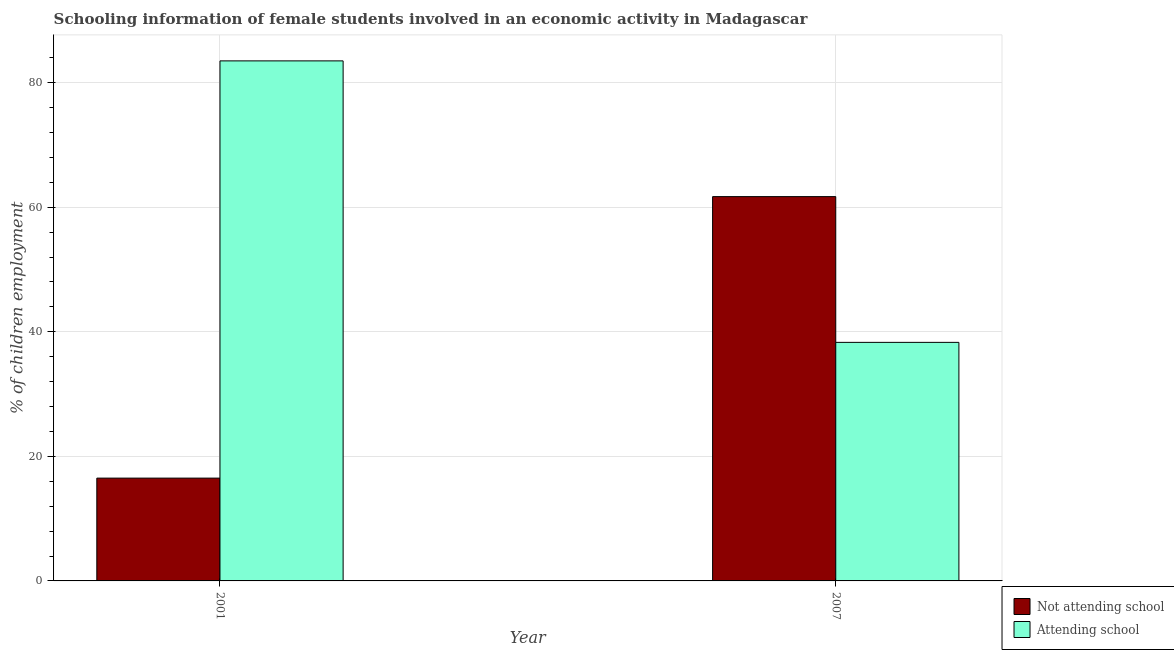How many different coloured bars are there?
Your response must be concise. 2. How many groups of bars are there?
Keep it short and to the point. 2. Are the number of bars per tick equal to the number of legend labels?
Your answer should be very brief. Yes. Are the number of bars on each tick of the X-axis equal?
Give a very brief answer. Yes. What is the percentage of employed females who are attending school in 2001?
Provide a short and direct response. 83.49. Across all years, what is the maximum percentage of employed females who are not attending school?
Offer a very short reply. 61.7. Across all years, what is the minimum percentage of employed females who are attending school?
Offer a very short reply. 38.3. What is the total percentage of employed females who are not attending school in the graph?
Make the answer very short. 78.21. What is the difference between the percentage of employed females who are not attending school in 2001 and that in 2007?
Provide a short and direct response. -45.19. What is the difference between the percentage of employed females who are not attending school in 2001 and the percentage of employed females who are attending school in 2007?
Offer a very short reply. -45.19. What is the average percentage of employed females who are not attending school per year?
Keep it short and to the point. 39.1. In how many years, is the percentage of employed females who are attending school greater than 28 %?
Your answer should be very brief. 2. What is the ratio of the percentage of employed females who are not attending school in 2001 to that in 2007?
Offer a very short reply. 0.27. Is the percentage of employed females who are not attending school in 2001 less than that in 2007?
Offer a terse response. Yes. In how many years, is the percentage of employed females who are not attending school greater than the average percentage of employed females who are not attending school taken over all years?
Offer a terse response. 1. What does the 2nd bar from the left in 2007 represents?
Provide a succinct answer. Attending school. What does the 1st bar from the right in 2007 represents?
Keep it short and to the point. Attending school. How many bars are there?
Offer a very short reply. 4. How many years are there in the graph?
Your answer should be very brief. 2. What is the difference between two consecutive major ticks on the Y-axis?
Provide a succinct answer. 20. Are the values on the major ticks of Y-axis written in scientific E-notation?
Make the answer very short. No. Where does the legend appear in the graph?
Keep it short and to the point. Bottom right. What is the title of the graph?
Your response must be concise. Schooling information of female students involved in an economic activity in Madagascar. Does "IMF concessional" appear as one of the legend labels in the graph?
Offer a very short reply. No. What is the label or title of the Y-axis?
Your response must be concise. % of children employment. What is the % of children employment in Not attending school in 2001?
Provide a short and direct response. 16.51. What is the % of children employment in Attending school in 2001?
Your answer should be very brief. 83.49. What is the % of children employment of Not attending school in 2007?
Provide a short and direct response. 61.7. What is the % of children employment in Attending school in 2007?
Offer a very short reply. 38.3. Across all years, what is the maximum % of children employment of Not attending school?
Your answer should be very brief. 61.7. Across all years, what is the maximum % of children employment in Attending school?
Keep it short and to the point. 83.49. Across all years, what is the minimum % of children employment in Not attending school?
Your response must be concise. 16.51. Across all years, what is the minimum % of children employment of Attending school?
Keep it short and to the point. 38.3. What is the total % of children employment of Not attending school in the graph?
Provide a succinct answer. 78.21. What is the total % of children employment of Attending school in the graph?
Give a very brief answer. 121.79. What is the difference between the % of children employment in Not attending school in 2001 and that in 2007?
Your response must be concise. -45.19. What is the difference between the % of children employment in Attending school in 2001 and that in 2007?
Your answer should be compact. 45.19. What is the difference between the % of children employment in Not attending school in 2001 and the % of children employment in Attending school in 2007?
Make the answer very short. -21.79. What is the average % of children employment of Not attending school per year?
Your answer should be very brief. 39.1. What is the average % of children employment in Attending school per year?
Give a very brief answer. 60.9. In the year 2001, what is the difference between the % of children employment of Not attending school and % of children employment of Attending school?
Provide a succinct answer. -66.99. In the year 2007, what is the difference between the % of children employment in Not attending school and % of children employment in Attending school?
Keep it short and to the point. 23.4. What is the ratio of the % of children employment in Not attending school in 2001 to that in 2007?
Your answer should be very brief. 0.27. What is the ratio of the % of children employment of Attending school in 2001 to that in 2007?
Provide a succinct answer. 2.18. What is the difference between the highest and the second highest % of children employment of Not attending school?
Your answer should be very brief. 45.19. What is the difference between the highest and the second highest % of children employment in Attending school?
Your answer should be compact. 45.19. What is the difference between the highest and the lowest % of children employment in Not attending school?
Your answer should be compact. 45.19. What is the difference between the highest and the lowest % of children employment in Attending school?
Make the answer very short. 45.19. 